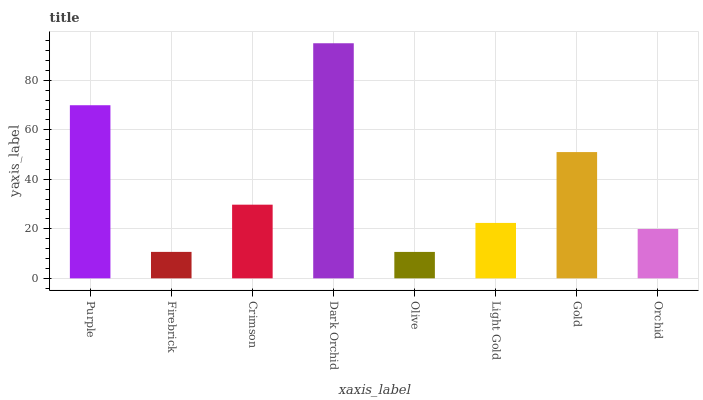Is Olive the minimum?
Answer yes or no. Yes. Is Dark Orchid the maximum?
Answer yes or no. Yes. Is Firebrick the minimum?
Answer yes or no. No. Is Firebrick the maximum?
Answer yes or no. No. Is Purple greater than Firebrick?
Answer yes or no. Yes. Is Firebrick less than Purple?
Answer yes or no. Yes. Is Firebrick greater than Purple?
Answer yes or no. No. Is Purple less than Firebrick?
Answer yes or no. No. Is Crimson the high median?
Answer yes or no. Yes. Is Light Gold the low median?
Answer yes or no. Yes. Is Purple the high median?
Answer yes or no. No. Is Firebrick the low median?
Answer yes or no. No. 